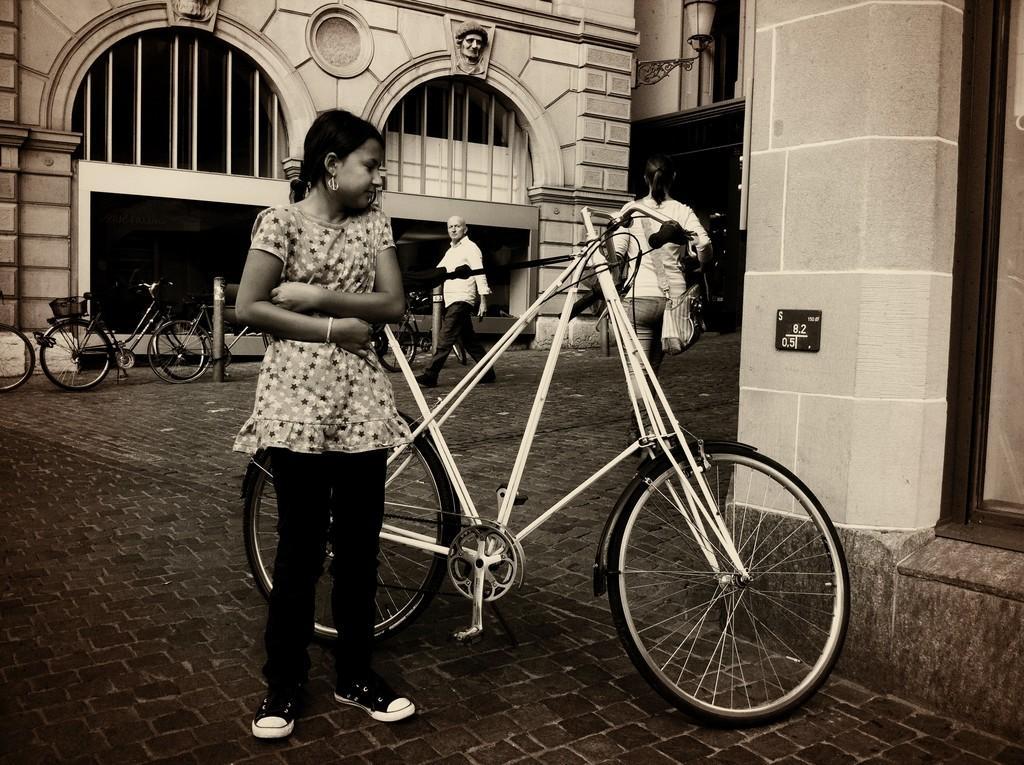How would you summarize this image in a sentence or two? This is black and white picture where we can see a girl is standing. Behind the girl bicycles are there and persons are walking on the road. We can see buildings. 